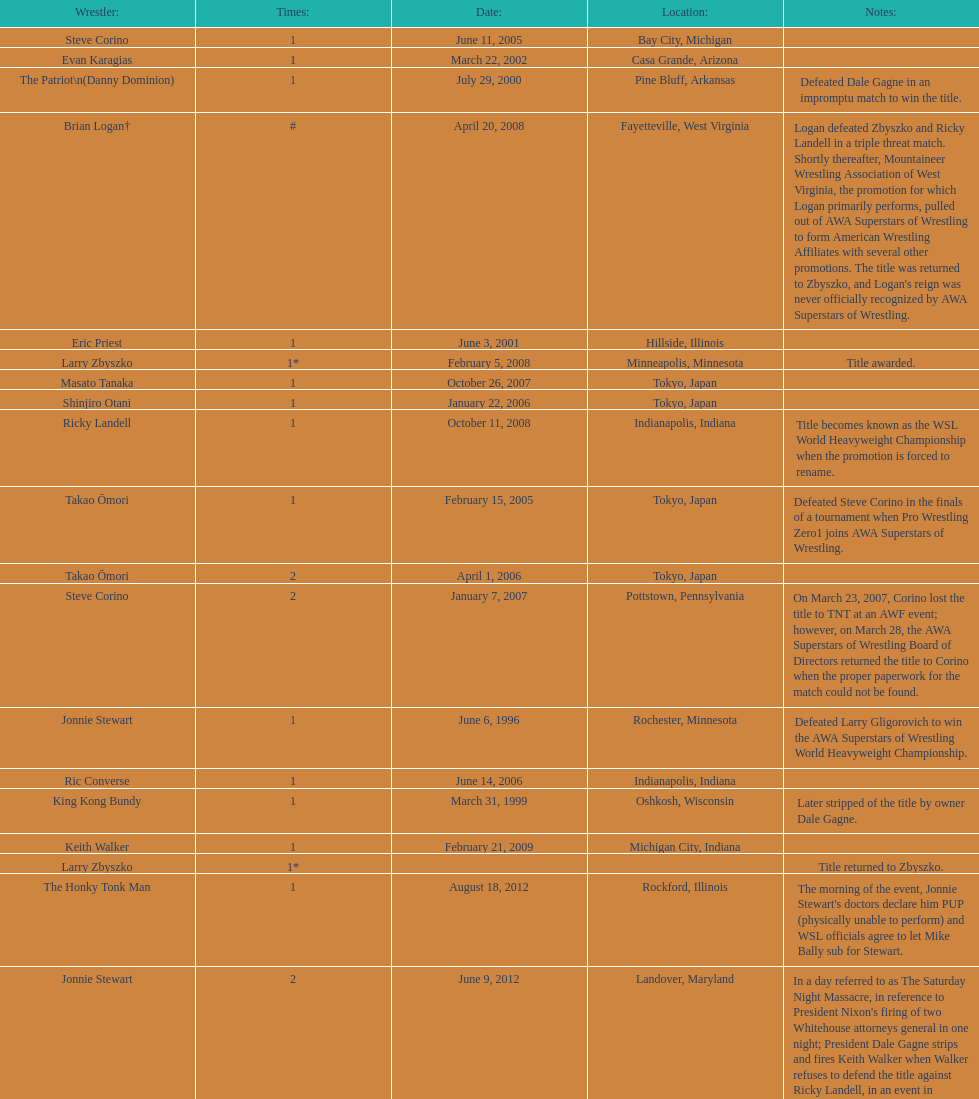Who is the only wsl title holder from texas? Horshu. 